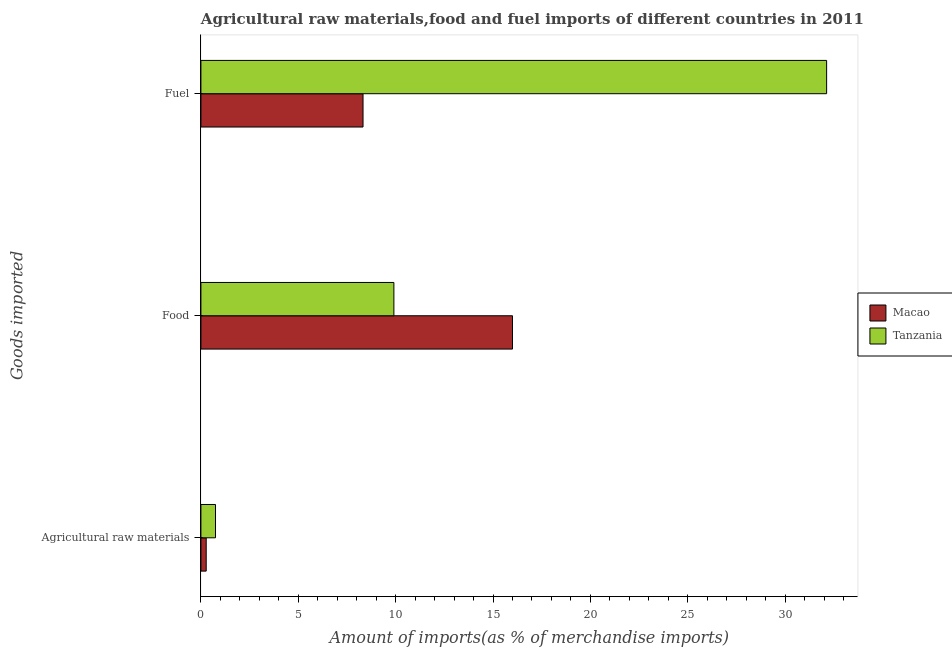How many different coloured bars are there?
Your answer should be very brief. 2. How many groups of bars are there?
Keep it short and to the point. 3. How many bars are there on the 2nd tick from the top?
Offer a very short reply. 2. How many bars are there on the 3rd tick from the bottom?
Make the answer very short. 2. What is the label of the 3rd group of bars from the top?
Offer a very short reply. Agricultural raw materials. What is the percentage of food imports in Macao?
Offer a very short reply. 16. Across all countries, what is the maximum percentage of fuel imports?
Your answer should be very brief. 32.13. Across all countries, what is the minimum percentage of fuel imports?
Your answer should be very brief. 8.33. In which country was the percentage of raw materials imports maximum?
Your answer should be compact. Tanzania. In which country was the percentage of raw materials imports minimum?
Offer a very short reply. Macao. What is the total percentage of food imports in the graph?
Keep it short and to the point. 25.91. What is the difference between the percentage of fuel imports in Macao and that in Tanzania?
Offer a very short reply. -23.81. What is the difference between the percentage of food imports in Macao and the percentage of fuel imports in Tanzania?
Keep it short and to the point. -16.13. What is the average percentage of food imports per country?
Your answer should be very brief. 12.96. What is the difference between the percentage of fuel imports and percentage of raw materials imports in Macao?
Offer a very short reply. 8.05. What is the ratio of the percentage of fuel imports in Macao to that in Tanzania?
Provide a succinct answer. 0.26. Is the difference between the percentage of raw materials imports in Macao and Tanzania greater than the difference between the percentage of food imports in Macao and Tanzania?
Provide a short and direct response. No. What is the difference between the highest and the second highest percentage of fuel imports?
Offer a very short reply. 23.81. What is the difference between the highest and the lowest percentage of food imports?
Keep it short and to the point. 6.09. In how many countries, is the percentage of raw materials imports greater than the average percentage of raw materials imports taken over all countries?
Your answer should be compact. 1. What does the 2nd bar from the top in Food represents?
Your response must be concise. Macao. What does the 1st bar from the bottom in Food represents?
Keep it short and to the point. Macao. What is the difference between two consecutive major ticks on the X-axis?
Ensure brevity in your answer.  5. Does the graph contain any zero values?
Your answer should be compact. No. Where does the legend appear in the graph?
Offer a very short reply. Center right. How many legend labels are there?
Provide a short and direct response. 2. How are the legend labels stacked?
Provide a succinct answer. Vertical. What is the title of the graph?
Keep it short and to the point. Agricultural raw materials,food and fuel imports of different countries in 2011. Does "Aruba" appear as one of the legend labels in the graph?
Offer a terse response. No. What is the label or title of the X-axis?
Provide a succinct answer. Amount of imports(as % of merchandise imports). What is the label or title of the Y-axis?
Offer a very short reply. Goods imported. What is the Amount of imports(as % of merchandise imports) in Macao in Agricultural raw materials?
Ensure brevity in your answer.  0.27. What is the Amount of imports(as % of merchandise imports) of Tanzania in Agricultural raw materials?
Offer a very short reply. 0.75. What is the Amount of imports(as % of merchandise imports) in Macao in Food?
Your answer should be very brief. 16. What is the Amount of imports(as % of merchandise imports) in Tanzania in Food?
Offer a very short reply. 9.91. What is the Amount of imports(as % of merchandise imports) in Macao in Fuel?
Provide a short and direct response. 8.33. What is the Amount of imports(as % of merchandise imports) in Tanzania in Fuel?
Provide a short and direct response. 32.13. Across all Goods imported, what is the maximum Amount of imports(as % of merchandise imports) in Macao?
Make the answer very short. 16. Across all Goods imported, what is the maximum Amount of imports(as % of merchandise imports) of Tanzania?
Offer a terse response. 32.13. Across all Goods imported, what is the minimum Amount of imports(as % of merchandise imports) of Macao?
Your response must be concise. 0.27. Across all Goods imported, what is the minimum Amount of imports(as % of merchandise imports) in Tanzania?
Provide a short and direct response. 0.75. What is the total Amount of imports(as % of merchandise imports) in Macao in the graph?
Keep it short and to the point. 24.6. What is the total Amount of imports(as % of merchandise imports) of Tanzania in the graph?
Your answer should be compact. 42.79. What is the difference between the Amount of imports(as % of merchandise imports) of Macao in Agricultural raw materials and that in Food?
Your answer should be very brief. -15.73. What is the difference between the Amount of imports(as % of merchandise imports) of Tanzania in Agricultural raw materials and that in Food?
Offer a terse response. -9.16. What is the difference between the Amount of imports(as % of merchandise imports) in Macao in Agricultural raw materials and that in Fuel?
Your response must be concise. -8.05. What is the difference between the Amount of imports(as % of merchandise imports) of Tanzania in Agricultural raw materials and that in Fuel?
Provide a short and direct response. -31.38. What is the difference between the Amount of imports(as % of merchandise imports) in Macao in Food and that in Fuel?
Your answer should be very brief. 7.68. What is the difference between the Amount of imports(as % of merchandise imports) in Tanzania in Food and that in Fuel?
Your answer should be compact. -22.22. What is the difference between the Amount of imports(as % of merchandise imports) in Macao in Agricultural raw materials and the Amount of imports(as % of merchandise imports) in Tanzania in Food?
Your answer should be very brief. -9.64. What is the difference between the Amount of imports(as % of merchandise imports) of Macao in Agricultural raw materials and the Amount of imports(as % of merchandise imports) of Tanzania in Fuel?
Give a very brief answer. -31.86. What is the difference between the Amount of imports(as % of merchandise imports) in Macao in Food and the Amount of imports(as % of merchandise imports) in Tanzania in Fuel?
Keep it short and to the point. -16.13. What is the average Amount of imports(as % of merchandise imports) of Macao per Goods imported?
Provide a short and direct response. 8.2. What is the average Amount of imports(as % of merchandise imports) of Tanzania per Goods imported?
Your answer should be very brief. 14.26. What is the difference between the Amount of imports(as % of merchandise imports) in Macao and Amount of imports(as % of merchandise imports) in Tanzania in Agricultural raw materials?
Your answer should be very brief. -0.48. What is the difference between the Amount of imports(as % of merchandise imports) in Macao and Amount of imports(as % of merchandise imports) in Tanzania in Food?
Keep it short and to the point. 6.09. What is the difference between the Amount of imports(as % of merchandise imports) of Macao and Amount of imports(as % of merchandise imports) of Tanzania in Fuel?
Keep it short and to the point. -23.81. What is the ratio of the Amount of imports(as % of merchandise imports) in Macao in Agricultural raw materials to that in Food?
Your answer should be compact. 0.02. What is the ratio of the Amount of imports(as % of merchandise imports) of Tanzania in Agricultural raw materials to that in Food?
Keep it short and to the point. 0.08. What is the ratio of the Amount of imports(as % of merchandise imports) in Macao in Agricultural raw materials to that in Fuel?
Your answer should be compact. 0.03. What is the ratio of the Amount of imports(as % of merchandise imports) in Tanzania in Agricultural raw materials to that in Fuel?
Your answer should be very brief. 0.02. What is the ratio of the Amount of imports(as % of merchandise imports) of Macao in Food to that in Fuel?
Offer a terse response. 1.92. What is the ratio of the Amount of imports(as % of merchandise imports) in Tanzania in Food to that in Fuel?
Your answer should be compact. 0.31. What is the difference between the highest and the second highest Amount of imports(as % of merchandise imports) of Macao?
Ensure brevity in your answer.  7.68. What is the difference between the highest and the second highest Amount of imports(as % of merchandise imports) of Tanzania?
Make the answer very short. 22.22. What is the difference between the highest and the lowest Amount of imports(as % of merchandise imports) in Macao?
Your answer should be very brief. 15.73. What is the difference between the highest and the lowest Amount of imports(as % of merchandise imports) of Tanzania?
Offer a very short reply. 31.38. 